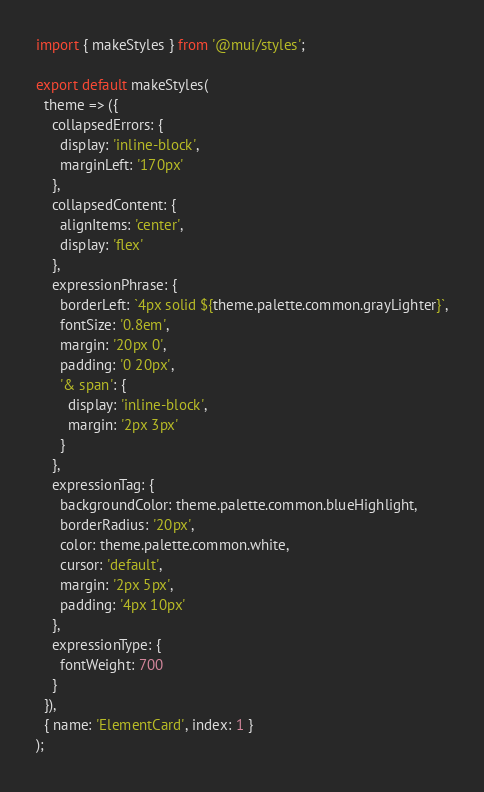<code> <loc_0><loc_0><loc_500><loc_500><_JavaScript_>import { makeStyles } from '@mui/styles';

export default makeStyles(
  theme => ({
    collapsedErrors: {
      display: 'inline-block',
      marginLeft: '170px'
    },
    collapsedContent: {
      alignItems: 'center',
      display: 'flex'
    },
    expressionPhrase: {
      borderLeft: `4px solid ${theme.palette.common.grayLighter}`,
      fontSize: '0.8em',
      margin: '20px 0',
      padding: '0 20px',
      '& span': {
        display: 'inline-block',
        margin: '2px 3px'
      }
    },
    expressionTag: {
      backgroundColor: theme.palette.common.blueHighlight,
      borderRadius: '20px',
      color: theme.palette.common.white,
      cursor: 'default',
      margin: '2px 5px',
      padding: '4px 10px'
    },
    expressionType: {
      fontWeight: 700
    }
  }),
  { name: 'ElementCard', index: 1 }
);
</code> 